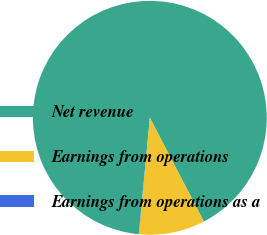Convert chart to OTSL. <chart><loc_0><loc_0><loc_500><loc_500><pie_chart><fcel>Net revenue<fcel>Earnings from operations<fcel>Earnings from operations as a<nl><fcel>90.83%<fcel>9.12%<fcel>0.04%<nl></chart> 